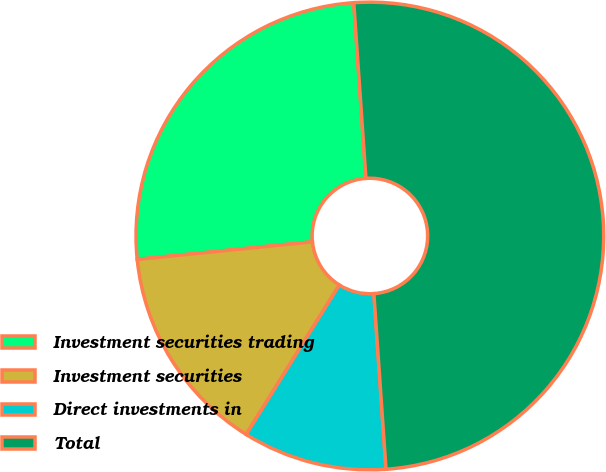<chart> <loc_0><loc_0><loc_500><loc_500><pie_chart><fcel>Investment securities trading<fcel>Investment securities<fcel>Direct investments in<fcel>Total<nl><fcel>25.5%<fcel>14.53%<fcel>9.97%<fcel>50.0%<nl></chart> 